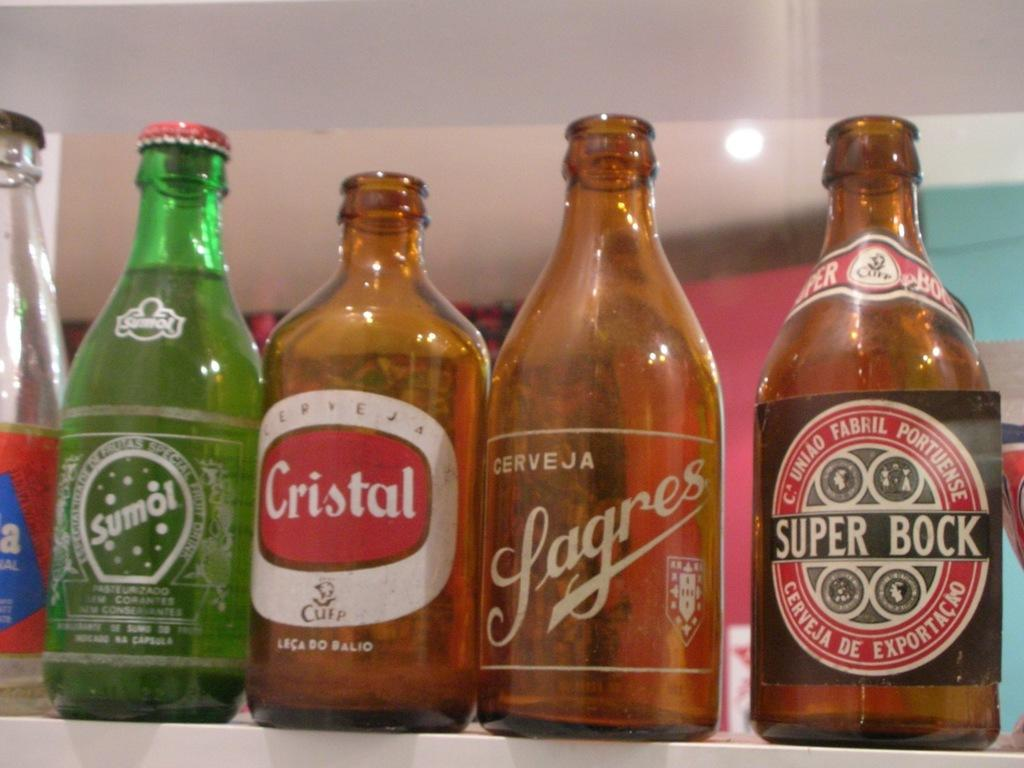What objects can be seen in the image? There are bottles and a light in the image. Can you describe the light in the image? Unfortunately, the provided facts do not give any details about the light, so we cannot describe it further. What type of instrument is being played by the pig in the image? There is no pig or instrument present in the image. 